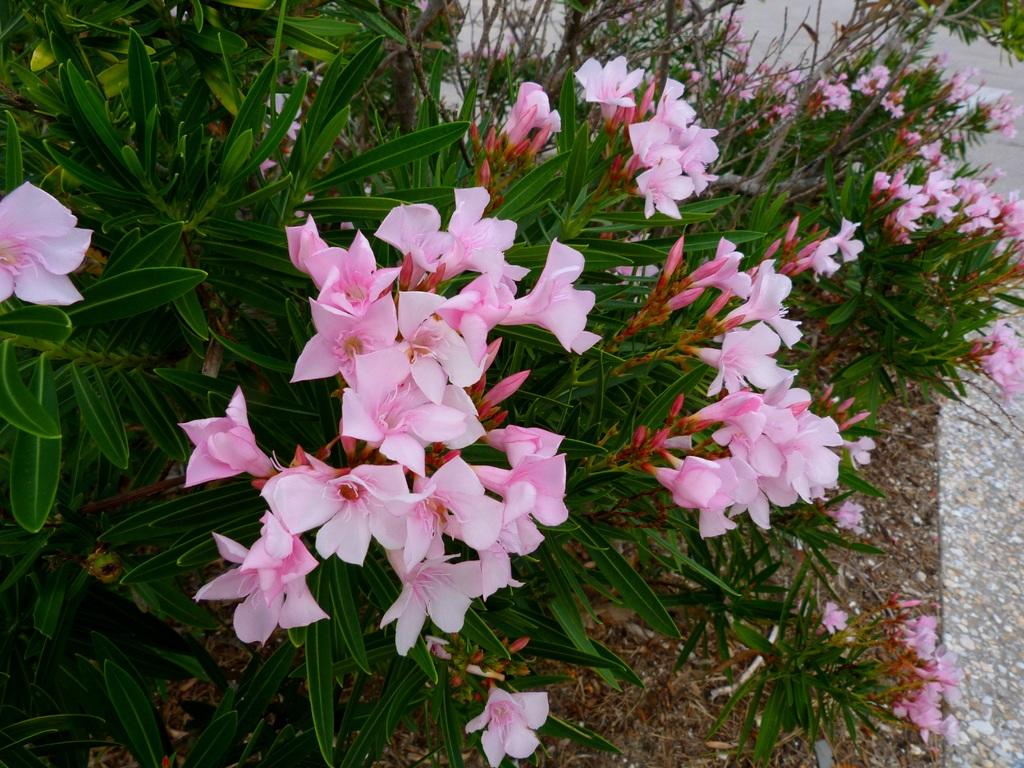What type of living organisms can be seen in the image? There are flowers in the image. What color are the flowers? The flowers are pink in color. What are the flowers growing on? The flowers are on plants. What color are the plants? The plants are green in color. What can be seen in the background of the image? The ground is visible in the background of the image. How many oranges are hanging from the plants in the image? There are no oranges present in the image; it features pink flowers on green plants. Is there any money visible in the image? There is no money visible in the image; it features flowers and plants. 